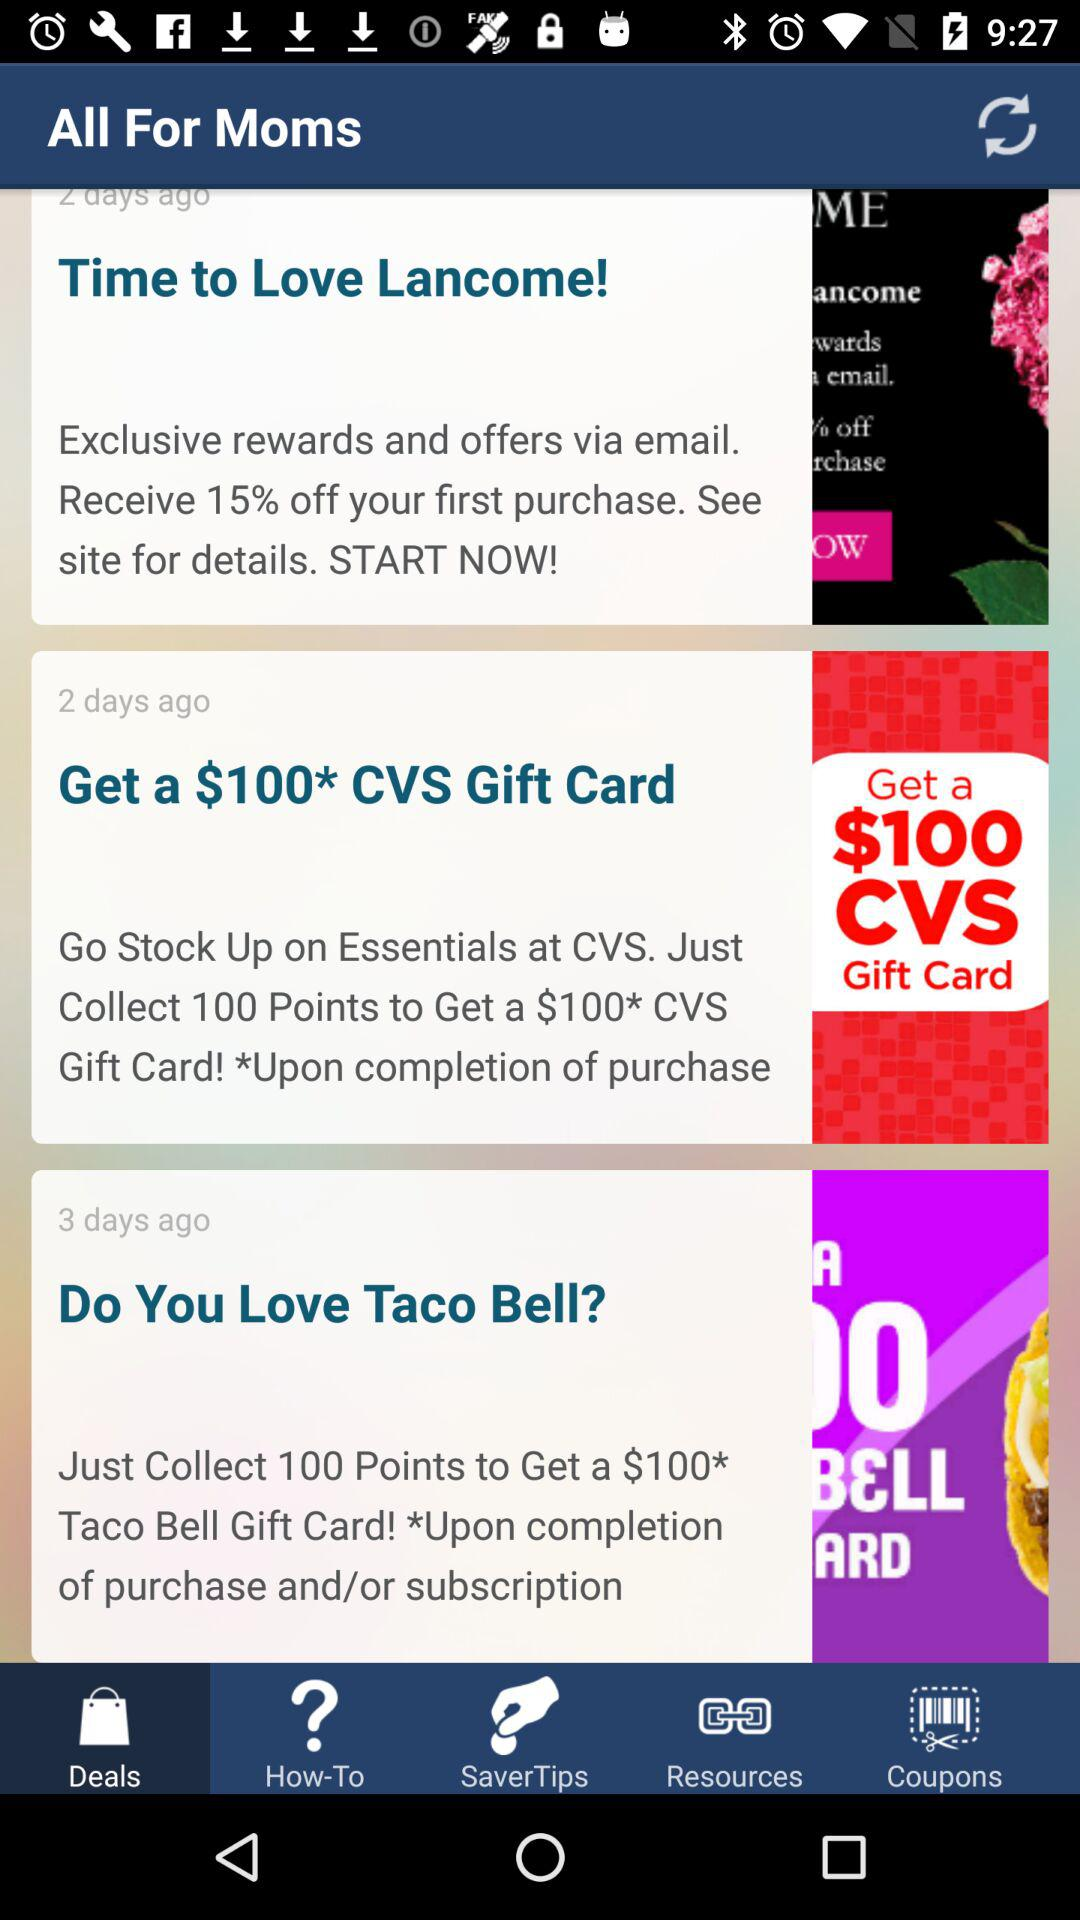How many days ago was the deal "Do You Love Taco Bell" posted? The deal "Do You Love Taco Bell" was posted 3 days ago. 